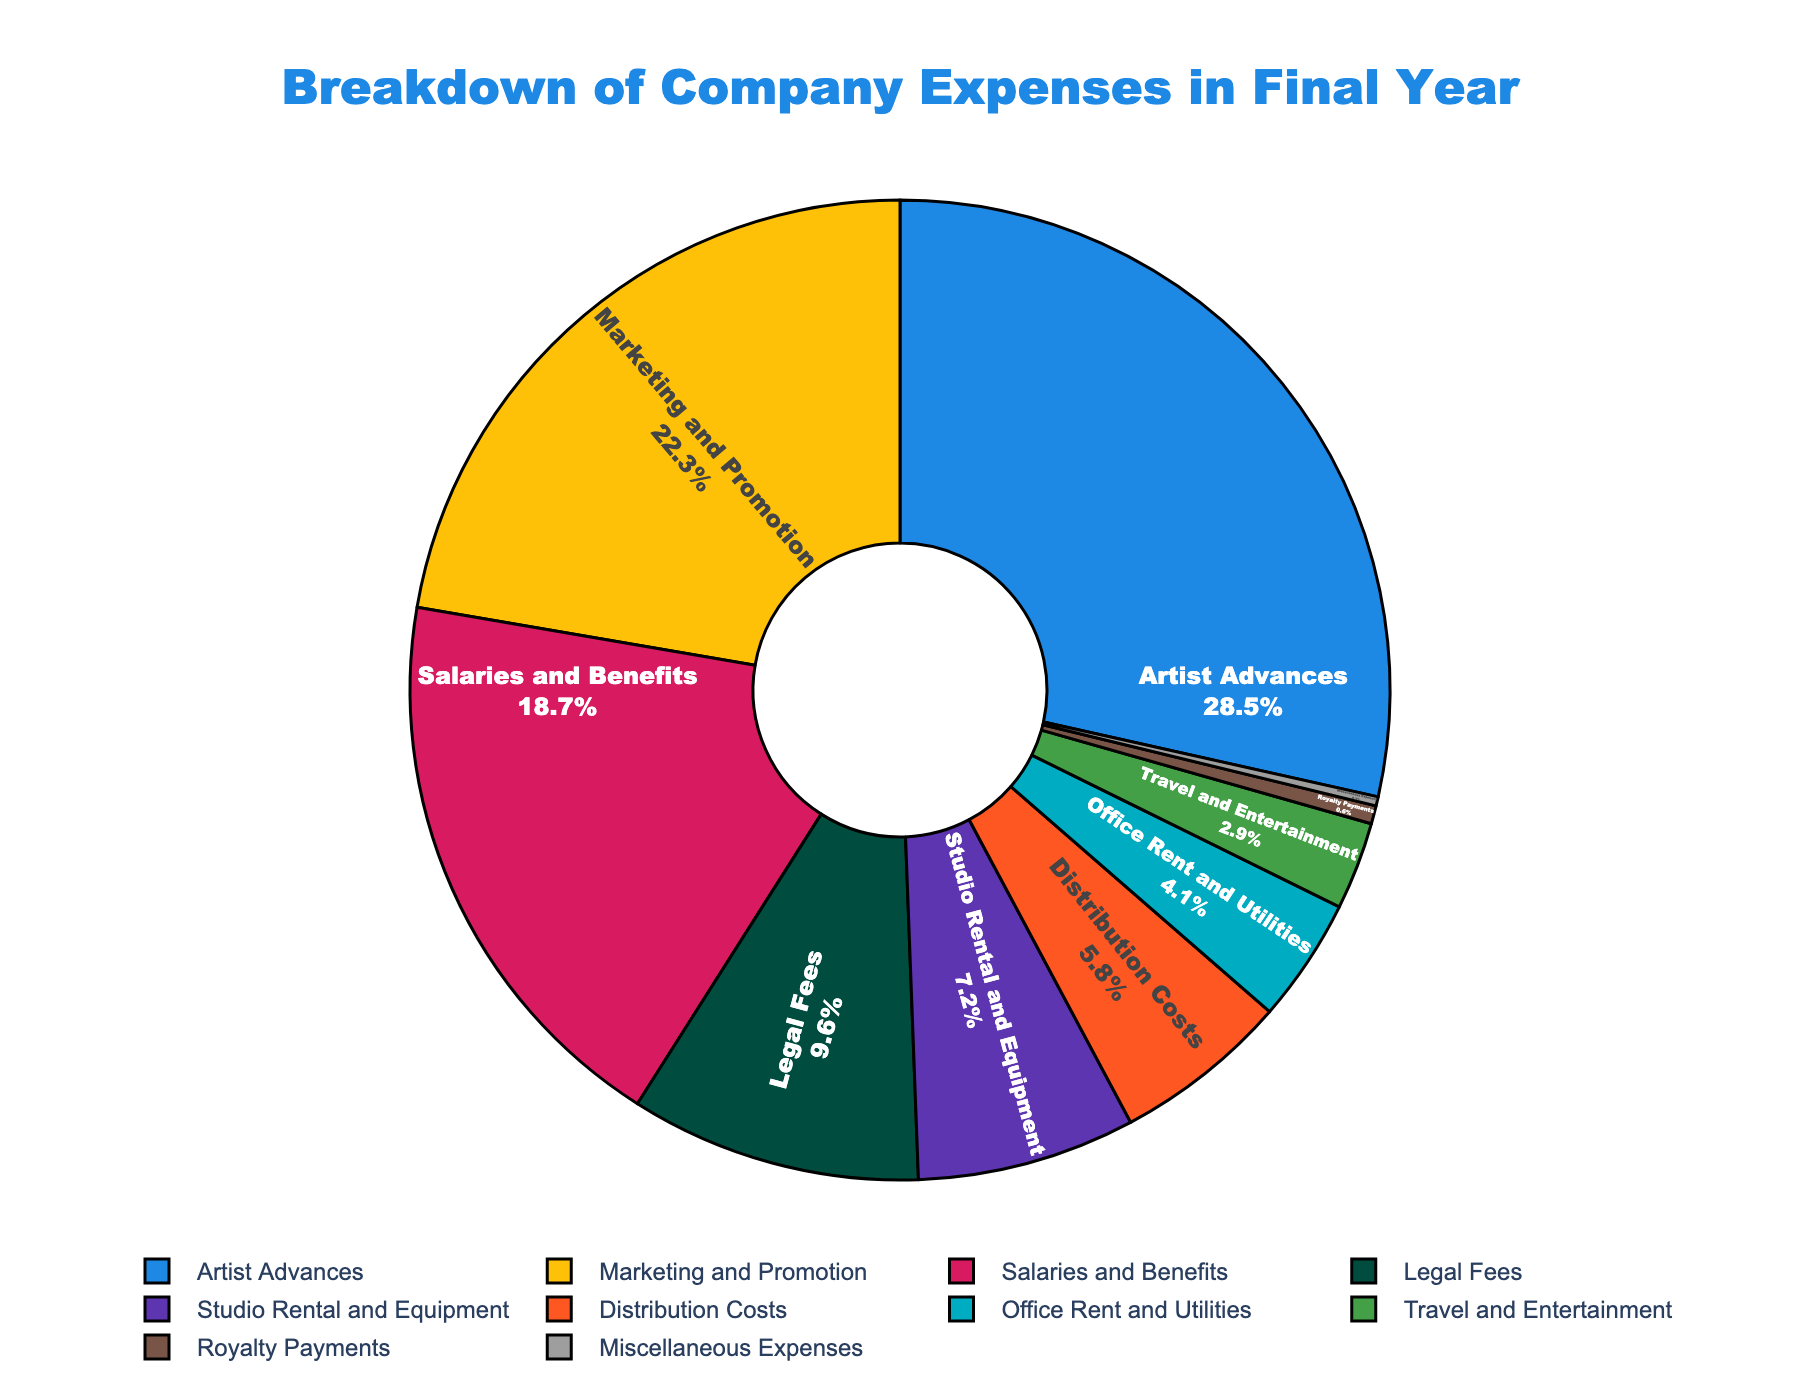What's the largest expense category? The pie chart shows various expense categories with their corresponding expense percentages. By looking at the proportions, "Artist Advances" has the largest slice, indicating it is the largest category.
Answer: Artist Advances Which expense category accounts for nearly a quarter of the total expenses? We need to identify the category whose expense percentage is close to 25%. "Marketing and Promotion" has an expense percentage of 22.3%, which is near a quarter of the total.
Answer: Marketing and Promotion What is the combined expense percentage for the three smallest categories? The three smallest categories are "Royalty Payments" (0.6%), "Miscellaneous Expenses" (0.3%), and "Travel and Entertainment" (2.9%). Adding these together: 0.6% + 0.3% + 2.9% = 3.8%.
Answer: 3.8% How many categories each constitute less than 10% of the total expenses? We count the categories with an expense percentage below 10%: Legal Fees (9.6%), Studio Rental and Equipment (7.2%), Distribution Costs (5.8%), Office Rent and Utilities (4.1%), Travel and Entertainment (2.9%), Royalty Payments (0.6%), and Miscellaneous Expenses (0.3%). There are 7 such categories.
Answer: 7 By how much does the "Salaries and Benefits" expense exceed the "Legal Fees" expense? "Salaries and Benefits" has an expense percentage of 18.7%, and "Legal Fees" has 9.6%. The difference is: 18.7% - 9.6% = 9.1%.
Answer: 9.1% Which expense category has a percentage closest to 20%? We observe the values and see that "Marketing and Promotion" has an expense percentage of 22.3%, which is the closest to 20%.
Answer: Marketing and Promotion Is the sum of "Marketing and Promotion" and "Salaries and Benefits" more than half of the total expenses? Adding the percentages for "Marketing and Promotion" (22.3%) and "Salaries and Benefits" (18.7%): 22.3% + 18.7% = 41%. Since 41% is less than 50%, their sum is not more than half of the total expenses.
Answer: No Which category occupies the smallest portion in the expenses chart? By identifying the smallest slice, "Miscellaneous Expenses" with 0.3% is the smallest category.
Answer: Miscellaneous Expenses What percentage do "Artist Advances" and "Marketing and Promotion" together represent? Adding "Artist Advances" (28.5%) and "Marketing and Promotion" (22.3%): 28.5% + 22.3% = 50.8%.
Answer: 50.8% Which category, depicted in green, represents the highest expense? Looking at the colors and matching them to categories, "Marketing and Promotion" is depicted in green and has the second-highest expense.
Answer: Marketing and Promotion 